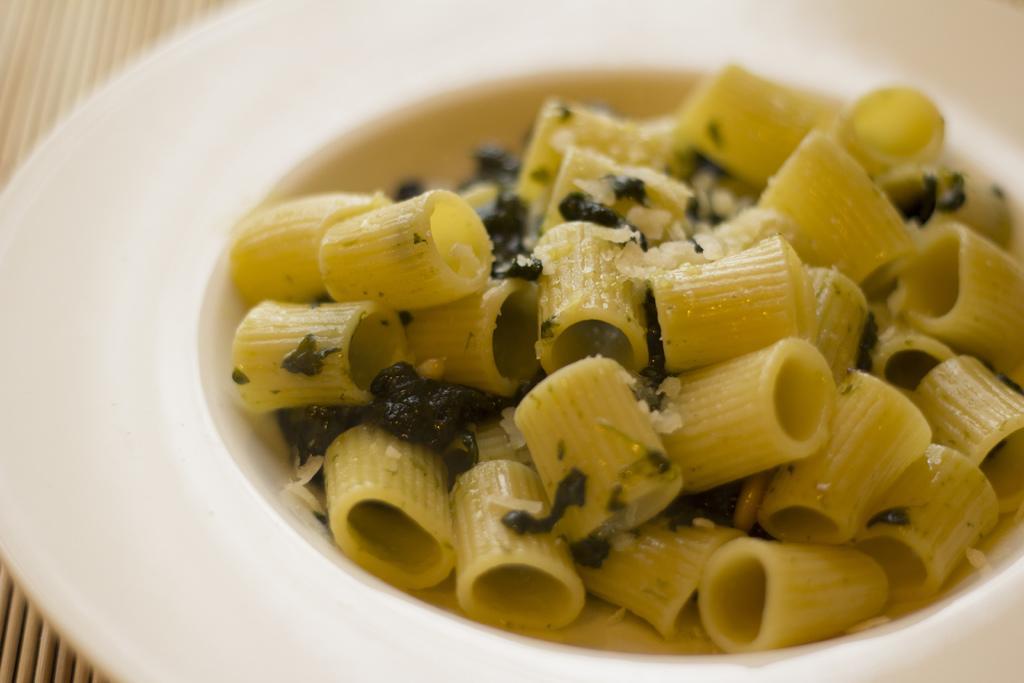Can you describe this image briefly? In this image there is a plate. On the plate there is a bowl. There is pasta with green leaves. 